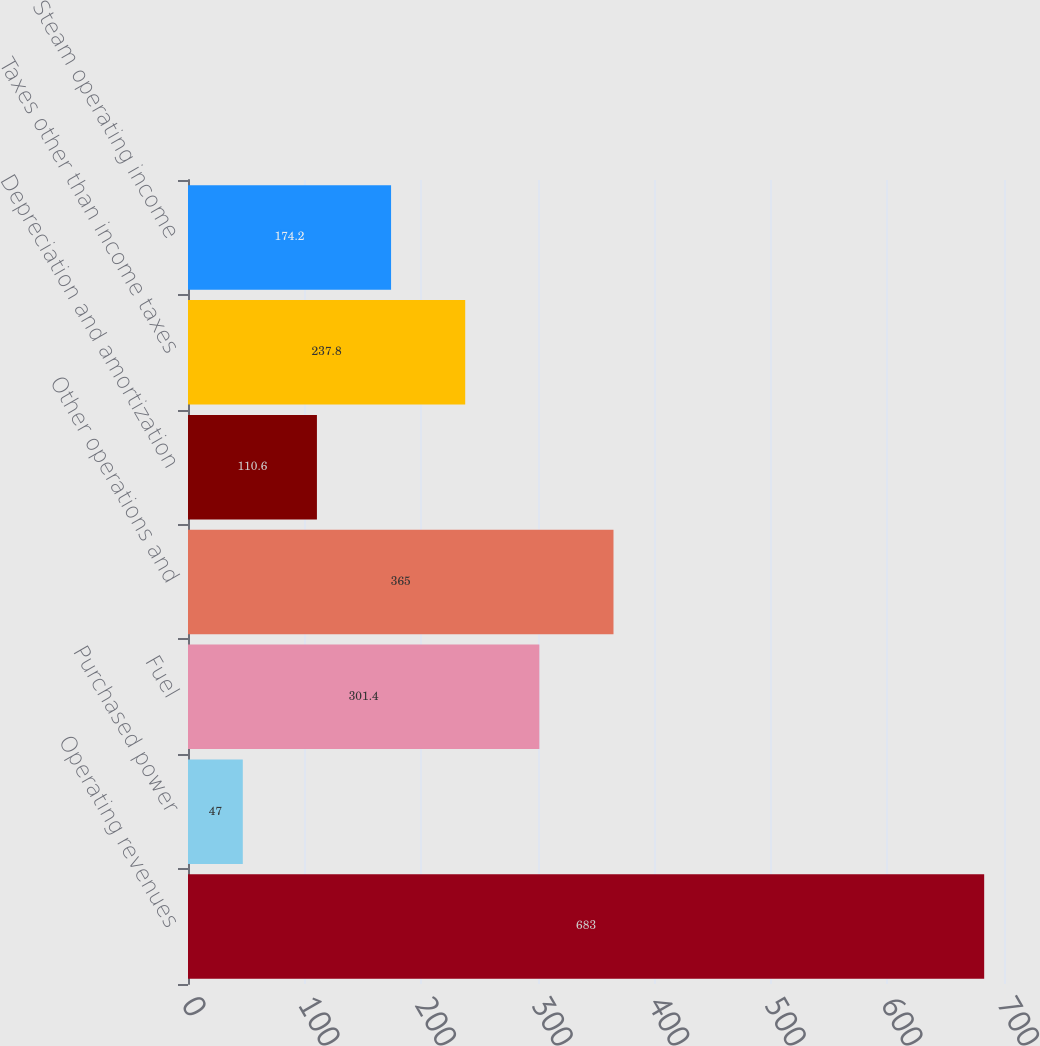<chart> <loc_0><loc_0><loc_500><loc_500><bar_chart><fcel>Operating revenues<fcel>Purchased power<fcel>Fuel<fcel>Other operations and<fcel>Depreciation and amortization<fcel>Taxes other than income taxes<fcel>Steam operating income<nl><fcel>683<fcel>47<fcel>301.4<fcel>365<fcel>110.6<fcel>237.8<fcel>174.2<nl></chart> 